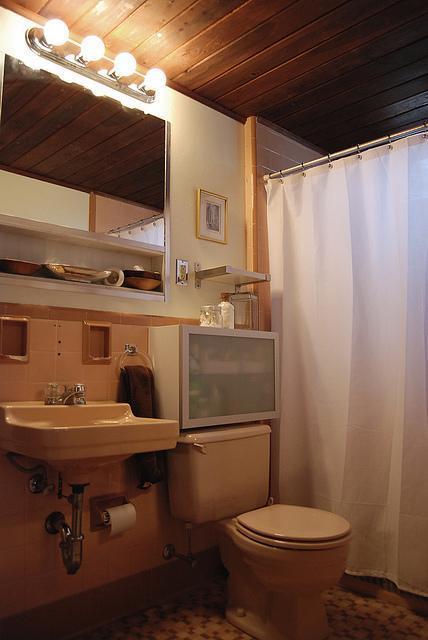How many rolls of toilet paper are visible?
Give a very brief answer. 1. How many urinals can be seen?
Give a very brief answer. 0. How many sinks are there?
Give a very brief answer. 1. How many men are wearing green underwear?
Give a very brief answer. 0. 